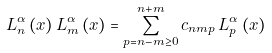<formula> <loc_0><loc_0><loc_500><loc_500>L _ { n } ^ { \alpha } \left ( x \right ) L _ { m } ^ { \alpha } \left ( x \right ) = \sum _ { p = n - m \geq 0 } ^ { n + m } c _ { n m p } \, L _ { p } ^ { \alpha } \left ( x \right )</formula> 